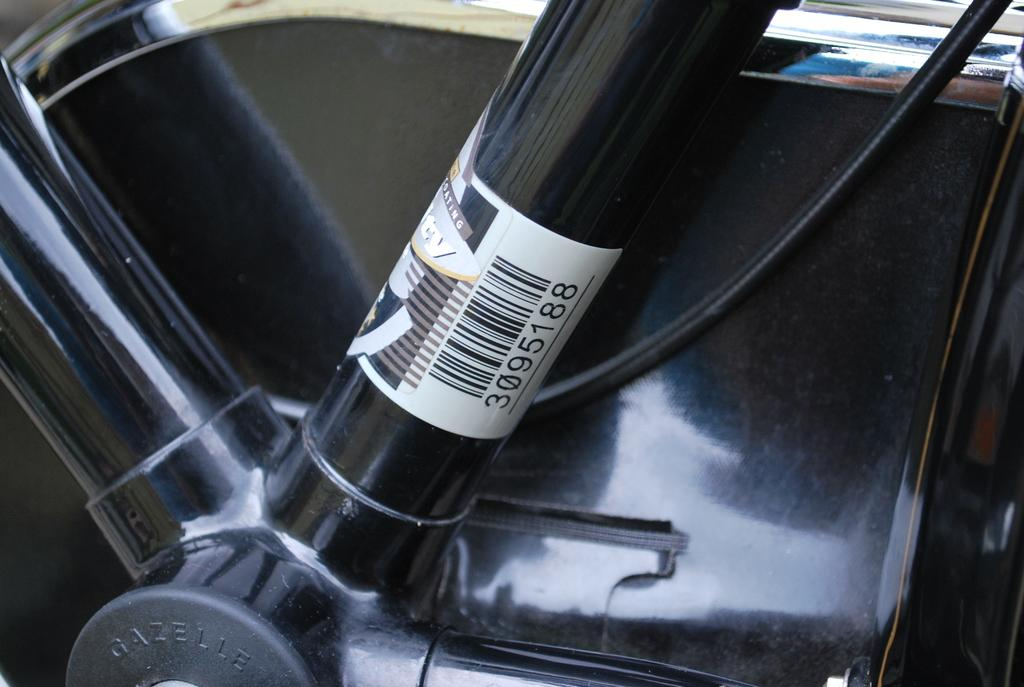What is the main subject of the image? The main subject of the image is a vehicle part. Is there any additional information provided on the vehicle part? Yes, there is a label on the vehicle part. What can be found on the label? The label contains a barcode. What type of information is present on the barcode? The barcode has numbers on it. What type of powder is used to create the attraction between the vehicle part and the label? There is no powder or attraction between the vehicle part and the label in the image. 